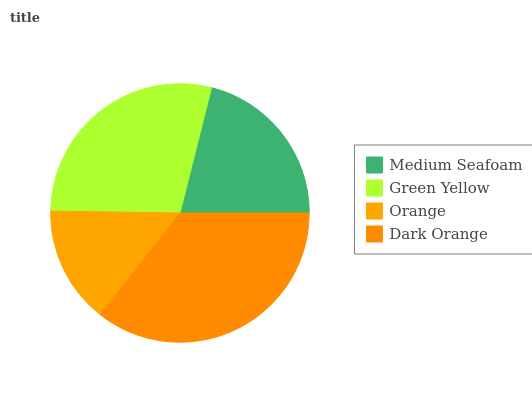Is Orange the minimum?
Answer yes or no. Yes. Is Dark Orange the maximum?
Answer yes or no. Yes. Is Green Yellow the minimum?
Answer yes or no. No. Is Green Yellow the maximum?
Answer yes or no. No. Is Green Yellow greater than Medium Seafoam?
Answer yes or no. Yes. Is Medium Seafoam less than Green Yellow?
Answer yes or no. Yes. Is Medium Seafoam greater than Green Yellow?
Answer yes or no. No. Is Green Yellow less than Medium Seafoam?
Answer yes or no. No. Is Green Yellow the high median?
Answer yes or no. Yes. Is Medium Seafoam the low median?
Answer yes or no. Yes. Is Medium Seafoam the high median?
Answer yes or no. No. Is Green Yellow the low median?
Answer yes or no. No. 